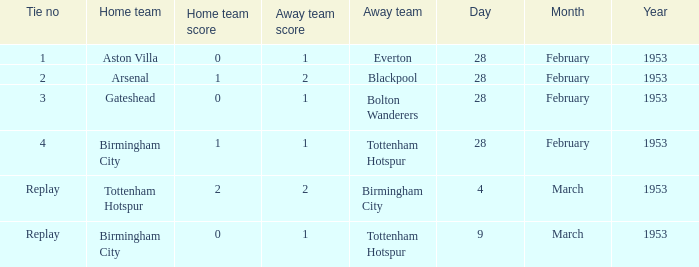Which score has a stalemate no of 1? 0–1. Parse the full table. {'header': ['Tie no', 'Home team', 'Home team score', 'Away team score', 'Away team', 'Day', 'Month', 'Year'], 'rows': [['1', 'Aston Villa', '0', '1', 'Everton', '28', 'February', '1953'], ['2', 'Arsenal', '1', '2', 'Blackpool', '28', 'February', '1953'], ['3', 'Gateshead', '0', '1', 'Bolton Wanderers', '28', 'February', '1953'], ['4', 'Birmingham City', '1', '1', 'Tottenham Hotspur', '28', 'February', '1953'], ['Replay', 'Tottenham Hotspur', '2', '2', 'Birmingham City', '4', 'March', '1953'], ['Replay', 'Birmingham City', '0', '1', 'Tottenham Hotspur', '9', 'March', '1953']]} 